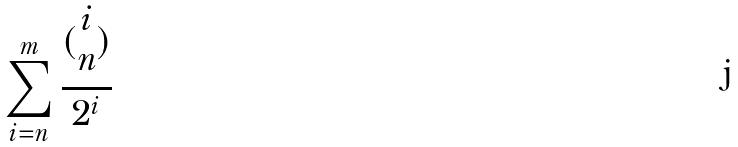<formula> <loc_0><loc_0><loc_500><loc_500>\sum _ { i = n } ^ { m } \frac { ( \begin{matrix} i \\ n \end{matrix} ) } { 2 ^ { i } }</formula> 